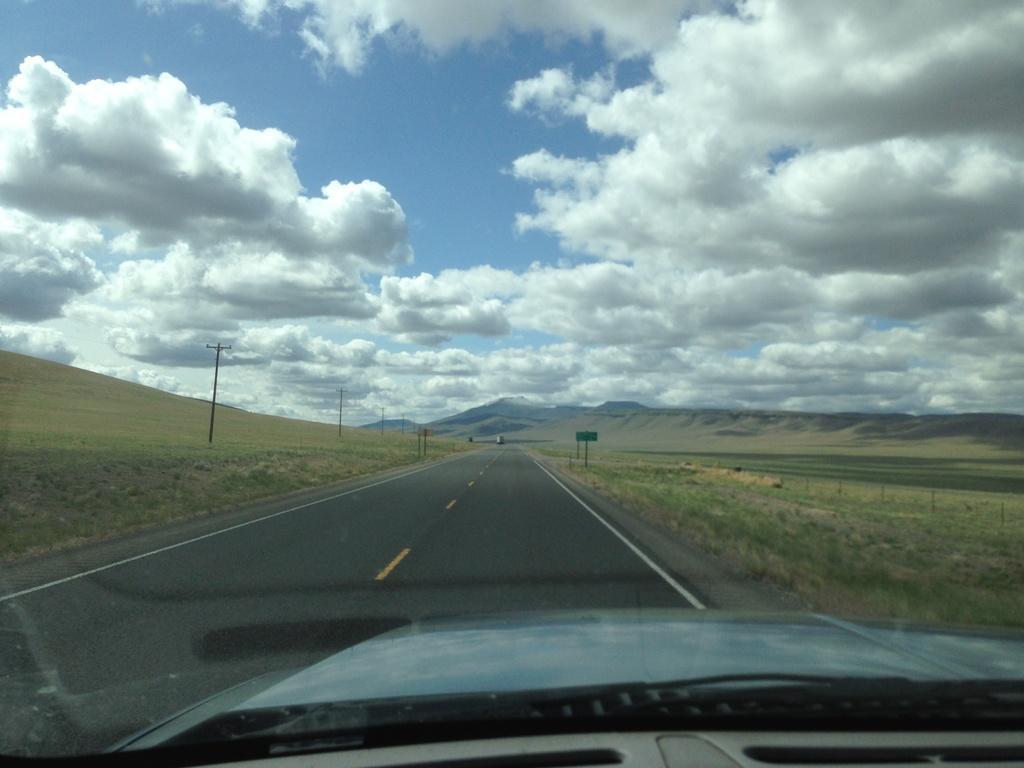Please provide a concise description of this image. In this image there is the sky towards the top of the image, there are clouds in the sky, there are mountains, there is grass, there are poles, there is a board, there is road, there is a vehicle towards the bottom of the image. 